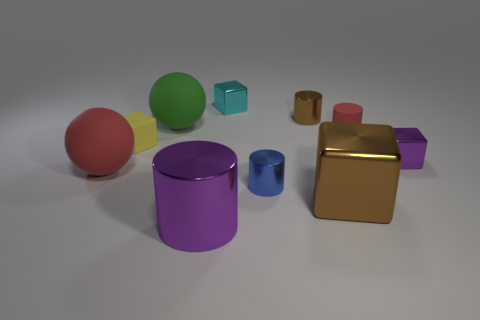Subtract all blue cylinders. How many cylinders are left? 3 Subtract all blue cylinders. How many cylinders are left? 3 Subtract 2 cylinders. How many cylinders are left? 2 Subtract all gray cylinders. Subtract all green spheres. How many cylinders are left? 4 Subtract all cylinders. How many objects are left? 6 Add 9 small yellow metal cylinders. How many small yellow metal cylinders exist? 9 Subtract 0 blue balls. How many objects are left? 10 Subtract all tiny brown shiny objects. Subtract all big matte balls. How many objects are left? 7 Add 9 matte blocks. How many matte blocks are left? 10 